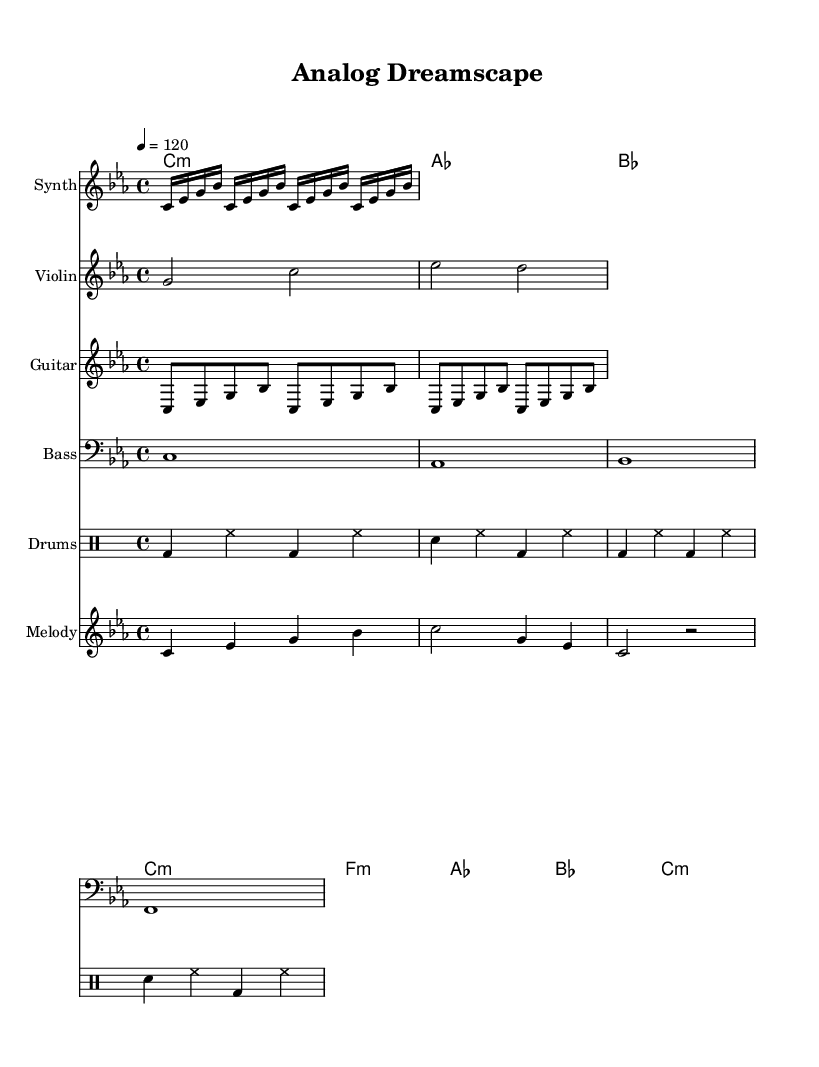What is the key signature of this music? The key signature is C minor, indicated by the presence of three flats (B flat, E flat, and A flat) in the key signature at the start of the score.
Answer: C minor What is the time signature of this piece? The time signature is 4/4, shown at the beginning of the score in the global section, which means there are four beats per measure and the quarter note gets one beat.
Answer: 4/4 What is the tempo marking for this piece? The tempo marking is 120 beats per minute, specified in the global section, where it states "4 = 120", indicating that there are 120 quarter note beats in a minute.
Answer: 120 How many measures are there in the synthesized arpeggio? The synthesized arpeggio section contains 4 measures because it is repeated four times, each repetition representing one measure of the 16th notes outlined in the synthArp part.
Answer: 4 What instrument plays the melody in this piece? The melody is played by the staff labeled "Melody," which is specifically designated for a melodic line separate from the other instruments, confirming it is notated for a singular melodic instrument or voice.
Answer: Melody What type of chord is used in the harmonies section? The chords in the harmonies section include C minor, A flat major, and F minor, showing a blend of minor and major qualities typical for harmonic progressions in experimental electronic fusion.
Answer: C minor, A flat major, F minor What rhythmic pattern is featured in the drums? The rhythmic pattern on the drums includes a bass drum backbeat combined with hi-hat and snare hits in a consistent 4/4 pattern, creating a standard dance music rhythmic foundation representative of the genre.
Answer: Bass drum backbeat 